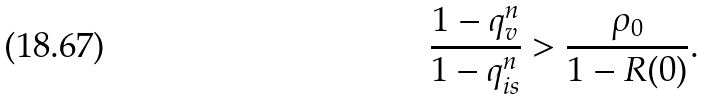<formula> <loc_0><loc_0><loc_500><loc_500>\frac { 1 - q _ { v } ^ { n } } { 1 - q _ { i s } ^ { n } } > \frac { \rho _ { 0 } } { 1 - R ( 0 ) } .</formula> 